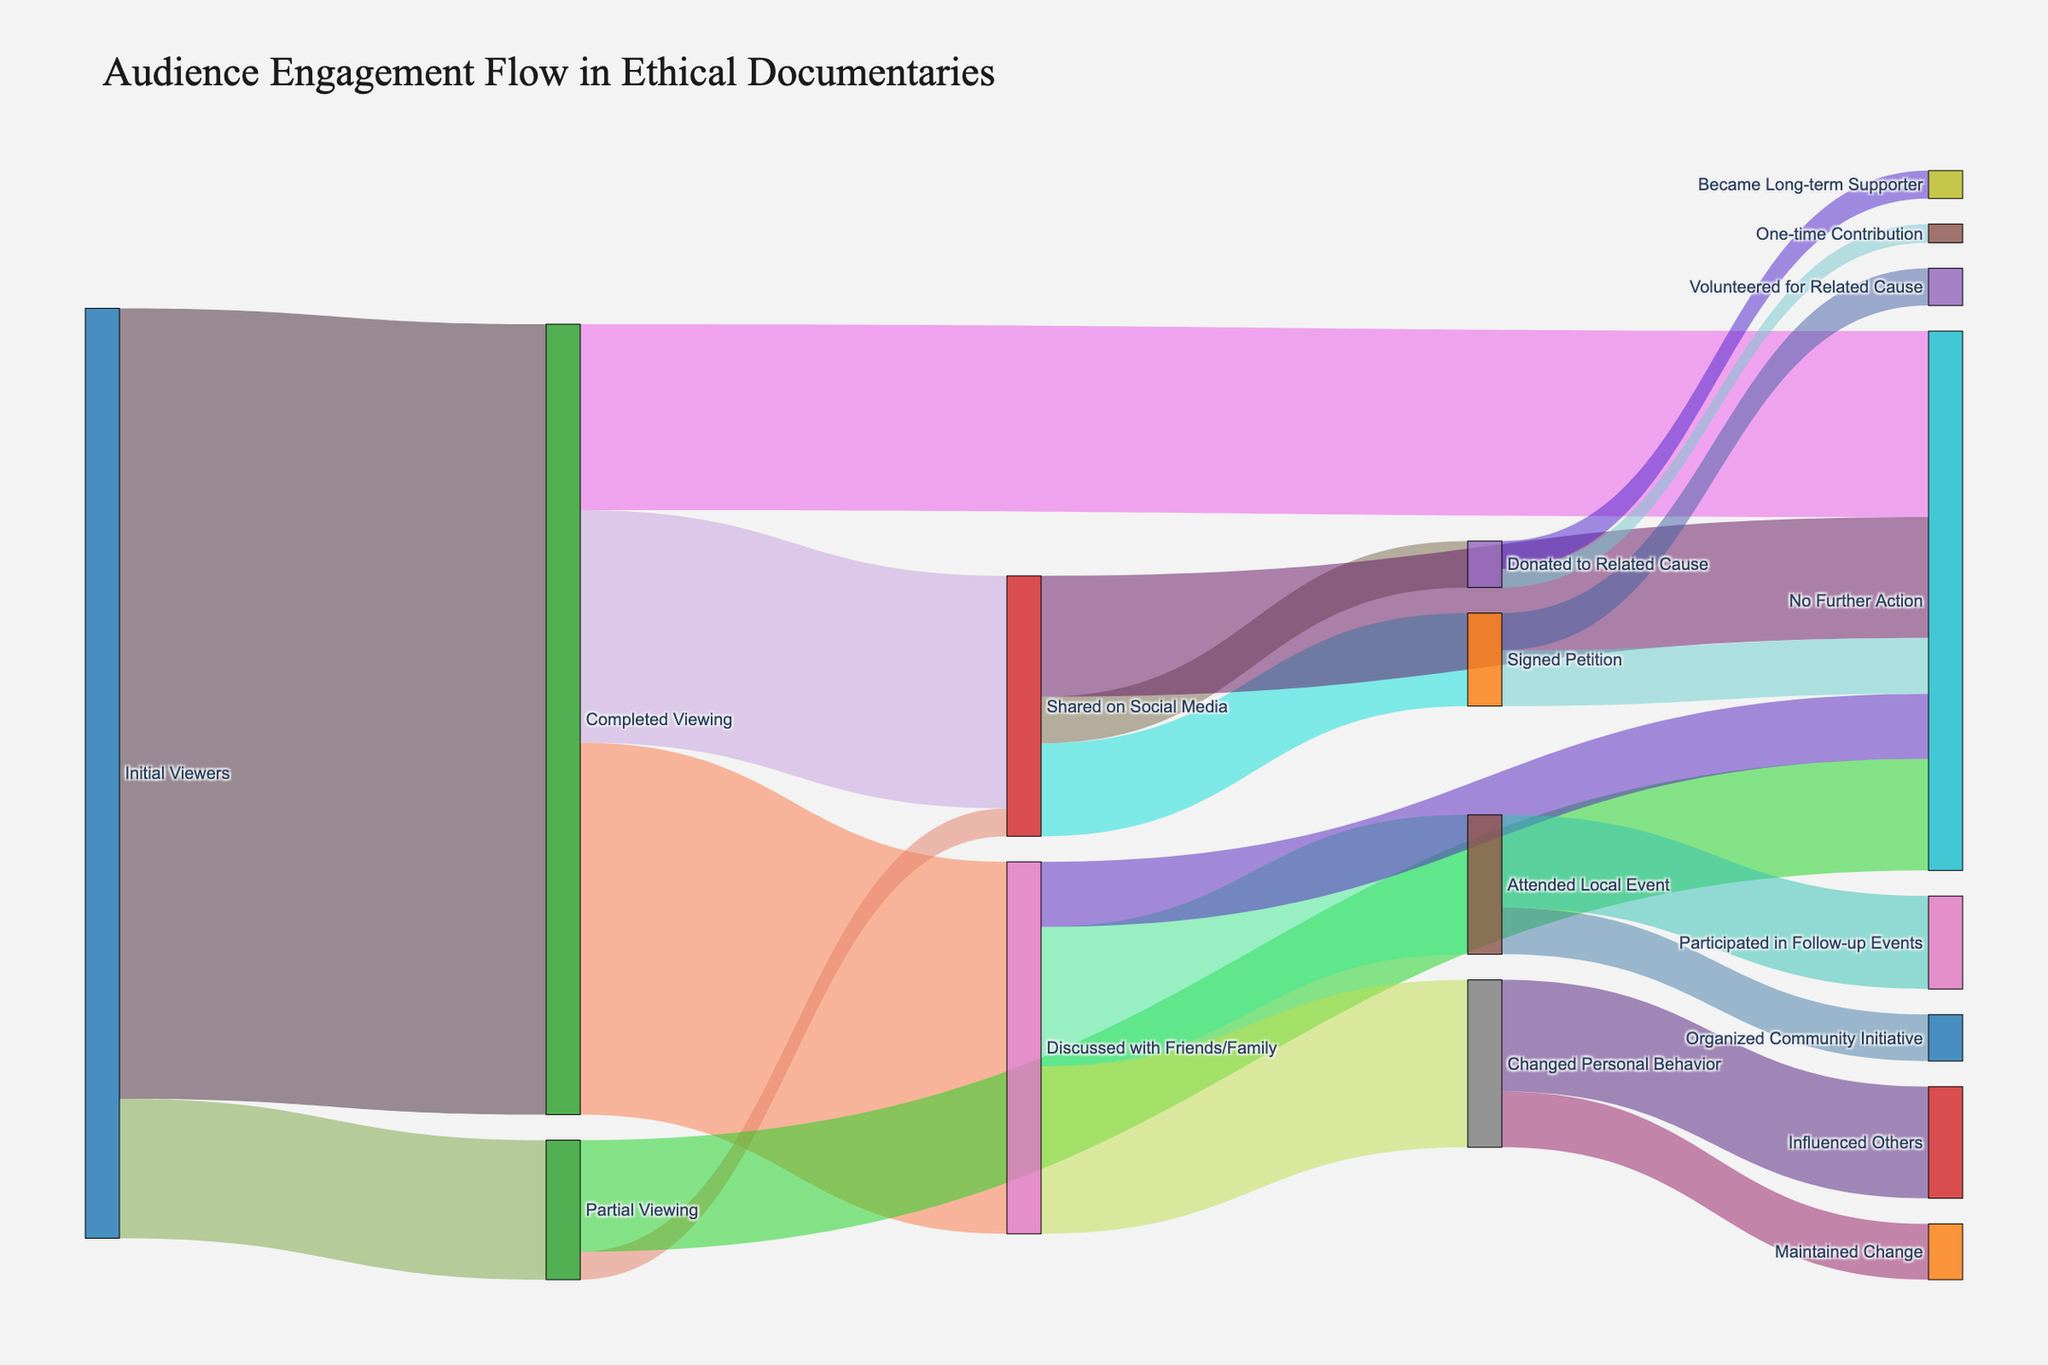Which action had the highest number of viewers discussing documentaries with friends or family? From the diagram, observing the flow from "Discussed with Friends/Family" reveals it splits into several actions. The highest number flows to "Changed Personal Behavior" with 180,000 viewers.
Answer: Changed Personal Behavior What is the total number of viewers who watched the documentaries partially or fully? Sum the viewers from "Initial Viewers" split into "Completed Viewing" (850,000) and "Partial Viewing" (150,000). The calculation is 850,000 + 150,000.
Answer: 1,000,000 Among viewers who completed the documentaries, which action did they take the least? Observing the split from "Completed Viewing" reveals the least number of viewers flowed to "No Further Action" with 200,000.
Answer: No Further Action How many viewers took action after viewing and discussing the documentaries? From "Discussed with Friends/Family," sum up those who "Attended Local Event" (150,000), "Changed Personal Behavior" (180,000), and exclude "No Further Action" (70,000). Calculation: 150,000 + 180,000 = 330,000.
Answer: 330,000 Which path led to the highest number of petition signers? Identify paths leading to "Signed Petition," the highest number of viewers came from "Shared on Social Media" at 100,000.
Answer: Shared on Social Media Compare the number of viewers who took no further action after completing versus partially viewing documentaries. From "Completed Viewing," 200,000 took no further action while from "Partial Viewing," 120,000 did not proceed further. Calculating: 200,000 - 120,000 = 80,000 difference.
Answer: 80,000 more from Completed Viewing What proportion of viewers who shared on social media ended up not taking further action? From "Shared on Social Media," calculate the proportion of those who did no further action (130,000) out of total (130,000 + 100,000 + 50,000). Calculation: 130,000 / (130,000 + 100,000 + 50,000) = 0.52 or 52%.
Answer: 52% How many viewers influenced others after changing their personal behavior? The Sankey diagram shows viewers flowing from "Changed Personal Behavior" to "Influenced Others" being 120,000.
Answer: 120,000 